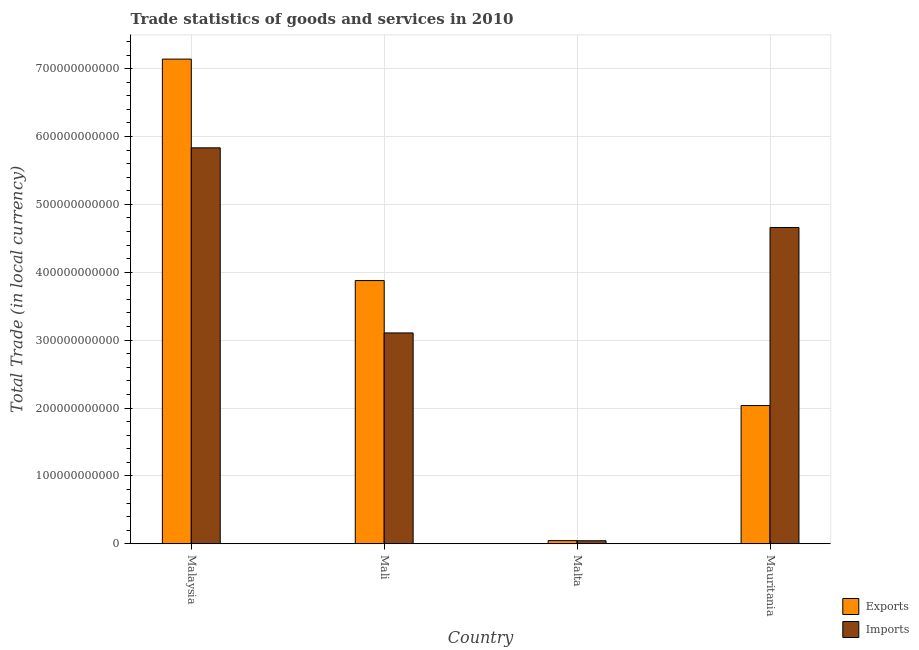How many different coloured bars are there?
Your response must be concise. 2. Are the number of bars per tick equal to the number of legend labels?
Your answer should be compact. Yes. Are the number of bars on each tick of the X-axis equal?
Provide a short and direct response. Yes. How many bars are there on the 2nd tick from the left?
Provide a succinct answer. 2. How many bars are there on the 2nd tick from the right?
Your response must be concise. 2. What is the label of the 2nd group of bars from the left?
Give a very brief answer. Mali. What is the imports of goods and services in Malta?
Your response must be concise. 4.40e+09. Across all countries, what is the maximum imports of goods and services?
Your answer should be very brief. 5.83e+11. Across all countries, what is the minimum export of goods and services?
Offer a terse response. 4.64e+09. In which country was the export of goods and services maximum?
Ensure brevity in your answer.  Malaysia. In which country was the export of goods and services minimum?
Your response must be concise. Malta. What is the total imports of goods and services in the graph?
Offer a terse response. 1.36e+12. What is the difference between the imports of goods and services in Malta and that in Mauritania?
Ensure brevity in your answer.  -4.62e+11. What is the difference between the imports of goods and services in Malaysia and the export of goods and services in Malta?
Provide a short and direct response. 5.79e+11. What is the average export of goods and services per country?
Provide a short and direct response. 3.28e+11. What is the difference between the imports of goods and services and export of goods and services in Mali?
Give a very brief answer. -7.72e+1. What is the ratio of the export of goods and services in Mali to that in Malta?
Your response must be concise. 83.59. Is the export of goods and services in Malaysia less than that in Mauritania?
Your answer should be compact. No. What is the difference between the highest and the second highest export of goods and services?
Offer a terse response. 3.26e+11. What is the difference between the highest and the lowest imports of goods and services?
Make the answer very short. 5.79e+11. In how many countries, is the export of goods and services greater than the average export of goods and services taken over all countries?
Keep it short and to the point. 2. What does the 2nd bar from the left in Malaysia represents?
Make the answer very short. Imports. What does the 1st bar from the right in Malaysia represents?
Your response must be concise. Imports. How many countries are there in the graph?
Offer a very short reply. 4. What is the difference between two consecutive major ticks on the Y-axis?
Your answer should be compact. 1.00e+11. Does the graph contain any zero values?
Ensure brevity in your answer.  No. Does the graph contain grids?
Ensure brevity in your answer.  Yes. How many legend labels are there?
Offer a terse response. 2. What is the title of the graph?
Your response must be concise. Trade statistics of goods and services in 2010. Does "International Visitors" appear as one of the legend labels in the graph?
Make the answer very short. No. What is the label or title of the Y-axis?
Your answer should be very brief. Total Trade (in local currency). What is the Total Trade (in local currency) in Exports in Malaysia?
Keep it short and to the point. 7.14e+11. What is the Total Trade (in local currency) of Imports in Malaysia?
Offer a very short reply. 5.83e+11. What is the Total Trade (in local currency) of Exports in Mali?
Your answer should be very brief. 3.88e+11. What is the Total Trade (in local currency) of Imports in Mali?
Keep it short and to the point. 3.11e+11. What is the Total Trade (in local currency) in Exports in Malta?
Your response must be concise. 4.64e+09. What is the Total Trade (in local currency) of Imports in Malta?
Your answer should be very brief. 4.40e+09. What is the Total Trade (in local currency) of Exports in Mauritania?
Make the answer very short. 2.04e+11. What is the Total Trade (in local currency) of Imports in Mauritania?
Give a very brief answer. 4.66e+11. Across all countries, what is the maximum Total Trade (in local currency) in Exports?
Offer a terse response. 7.14e+11. Across all countries, what is the maximum Total Trade (in local currency) of Imports?
Your answer should be compact. 5.83e+11. Across all countries, what is the minimum Total Trade (in local currency) in Exports?
Keep it short and to the point. 4.64e+09. Across all countries, what is the minimum Total Trade (in local currency) in Imports?
Provide a succinct answer. 4.40e+09. What is the total Total Trade (in local currency) in Exports in the graph?
Provide a succinct answer. 1.31e+12. What is the total Total Trade (in local currency) of Imports in the graph?
Offer a terse response. 1.36e+12. What is the difference between the Total Trade (in local currency) in Exports in Malaysia and that in Mali?
Offer a very short reply. 3.26e+11. What is the difference between the Total Trade (in local currency) of Imports in Malaysia and that in Mali?
Your answer should be very brief. 2.73e+11. What is the difference between the Total Trade (in local currency) in Exports in Malaysia and that in Malta?
Give a very brief answer. 7.09e+11. What is the difference between the Total Trade (in local currency) of Imports in Malaysia and that in Malta?
Ensure brevity in your answer.  5.79e+11. What is the difference between the Total Trade (in local currency) of Exports in Malaysia and that in Mauritania?
Your answer should be very brief. 5.10e+11. What is the difference between the Total Trade (in local currency) in Imports in Malaysia and that in Mauritania?
Keep it short and to the point. 1.17e+11. What is the difference between the Total Trade (in local currency) in Exports in Mali and that in Malta?
Give a very brief answer. 3.83e+11. What is the difference between the Total Trade (in local currency) of Imports in Mali and that in Malta?
Your answer should be compact. 3.06e+11. What is the difference between the Total Trade (in local currency) of Exports in Mali and that in Mauritania?
Give a very brief answer. 1.84e+11. What is the difference between the Total Trade (in local currency) in Imports in Mali and that in Mauritania?
Your answer should be very brief. -1.55e+11. What is the difference between the Total Trade (in local currency) of Exports in Malta and that in Mauritania?
Your response must be concise. -1.99e+11. What is the difference between the Total Trade (in local currency) in Imports in Malta and that in Mauritania?
Keep it short and to the point. -4.62e+11. What is the difference between the Total Trade (in local currency) of Exports in Malaysia and the Total Trade (in local currency) of Imports in Mali?
Keep it short and to the point. 4.03e+11. What is the difference between the Total Trade (in local currency) of Exports in Malaysia and the Total Trade (in local currency) of Imports in Malta?
Make the answer very short. 7.10e+11. What is the difference between the Total Trade (in local currency) in Exports in Malaysia and the Total Trade (in local currency) in Imports in Mauritania?
Give a very brief answer. 2.48e+11. What is the difference between the Total Trade (in local currency) in Exports in Mali and the Total Trade (in local currency) in Imports in Malta?
Provide a succinct answer. 3.83e+11. What is the difference between the Total Trade (in local currency) in Exports in Mali and the Total Trade (in local currency) in Imports in Mauritania?
Give a very brief answer. -7.82e+1. What is the difference between the Total Trade (in local currency) of Exports in Malta and the Total Trade (in local currency) of Imports in Mauritania?
Offer a terse response. -4.61e+11. What is the average Total Trade (in local currency) in Exports per country?
Give a very brief answer. 3.28e+11. What is the average Total Trade (in local currency) of Imports per country?
Your answer should be very brief. 3.41e+11. What is the difference between the Total Trade (in local currency) in Exports and Total Trade (in local currency) in Imports in Malaysia?
Give a very brief answer. 1.31e+11. What is the difference between the Total Trade (in local currency) of Exports and Total Trade (in local currency) of Imports in Mali?
Offer a very short reply. 7.72e+1. What is the difference between the Total Trade (in local currency) in Exports and Total Trade (in local currency) in Imports in Malta?
Provide a succinct answer. 2.38e+08. What is the difference between the Total Trade (in local currency) in Exports and Total Trade (in local currency) in Imports in Mauritania?
Your answer should be compact. -2.62e+11. What is the ratio of the Total Trade (in local currency) in Exports in Malaysia to that in Mali?
Ensure brevity in your answer.  1.84. What is the ratio of the Total Trade (in local currency) in Imports in Malaysia to that in Mali?
Make the answer very short. 1.88. What is the ratio of the Total Trade (in local currency) in Exports in Malaysia to that in Malta?
Provide a short and direct response. 153.93. What is the ratio of the Total Trade (in local currency) of Imports in Malaysia to that in Malta?
Provide a short and direct response. 132.55. What is the ratio of the Total Trade (in local currency) of Exports in Malaysia to that in Mauritania?
Provide a short and direct response. 3.51. What is the ratio of the Total Trade (in local currency) of Imports in Malaysia to that in Mauritania?
Your answer should be very brief. 1.25. What is the ratio of the Total Trade (in local currency) of Exports in Mali to that in Malta?
Ensure brevity in your answer.  83.59. What is the ratio of the Total Trade (in local currency) of Imports in Mali to that in Malta?
Offer a terse response. 70.58. What is the ratio of the Total Trade (in local currency) in Exports in Mali to that in Mauritania?
Your response must be concise. 1.9. What is the ratio of the Total Trade (in local currency) of Imports in Mali to that in Mauritania?
Make the answer very short. 0.67. What is the ratio of the Total Trade (in local currency) in Exports in Malta to that in Mauritania?
Give a very brief answer. 0.02. What is the ratio of the Total Trade (in local currency) of Imports in Malta to that in Mauritania?
Your answer should be very brief. 0.01. What is the difference between the highest and the second highest Total Trade (in local currency) of Exports?
Give a very brief answer. 3.26e+11. What is the difference between the highest and the second highest Total Trade (in local currency) in Imports?
Your answer should be very brief. 1.17e+11. What is the difference between the highest and the lowest Total Trade (in local currency) of Exports?
Provide a short and direct response. 7.09e+11. What is the difference between the highest and the lowest Total Trade (in local currency) of Imports?
Your answer should be very brief. 5.79e+11. 